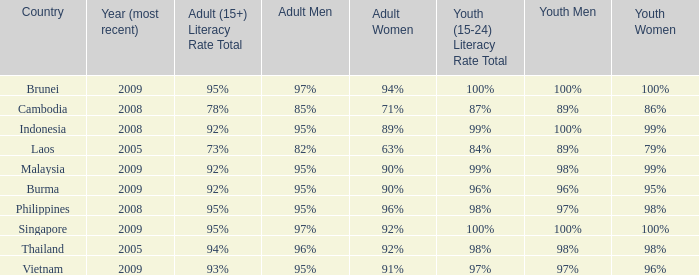Which country has its most recent year as being 2005 and has an Adult Men literacy rate of 96%? Thailand. 